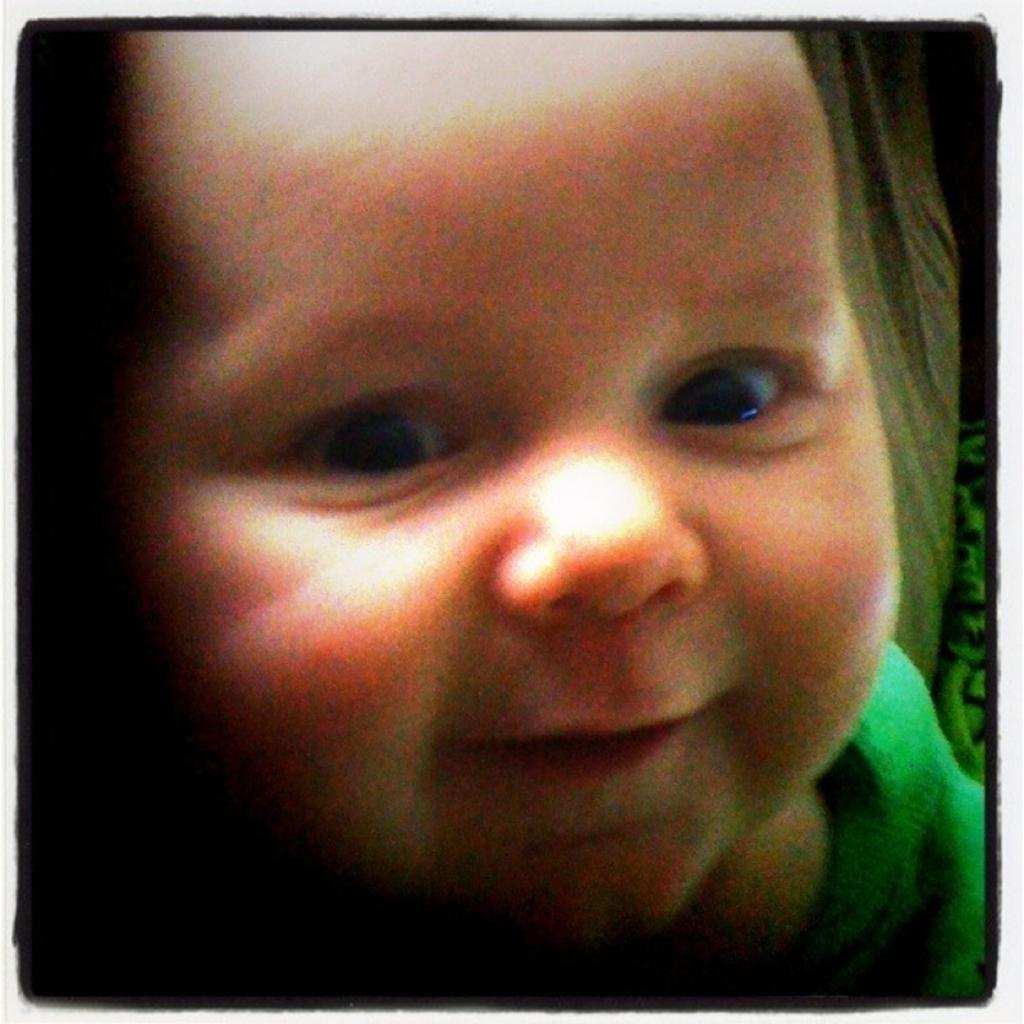What is the main subject of the image? The main subject of the image is a picture of a baby. What type of sign can be seen near the baby in the image? There is no sign present in the image; it only contains a picture of a baby. 